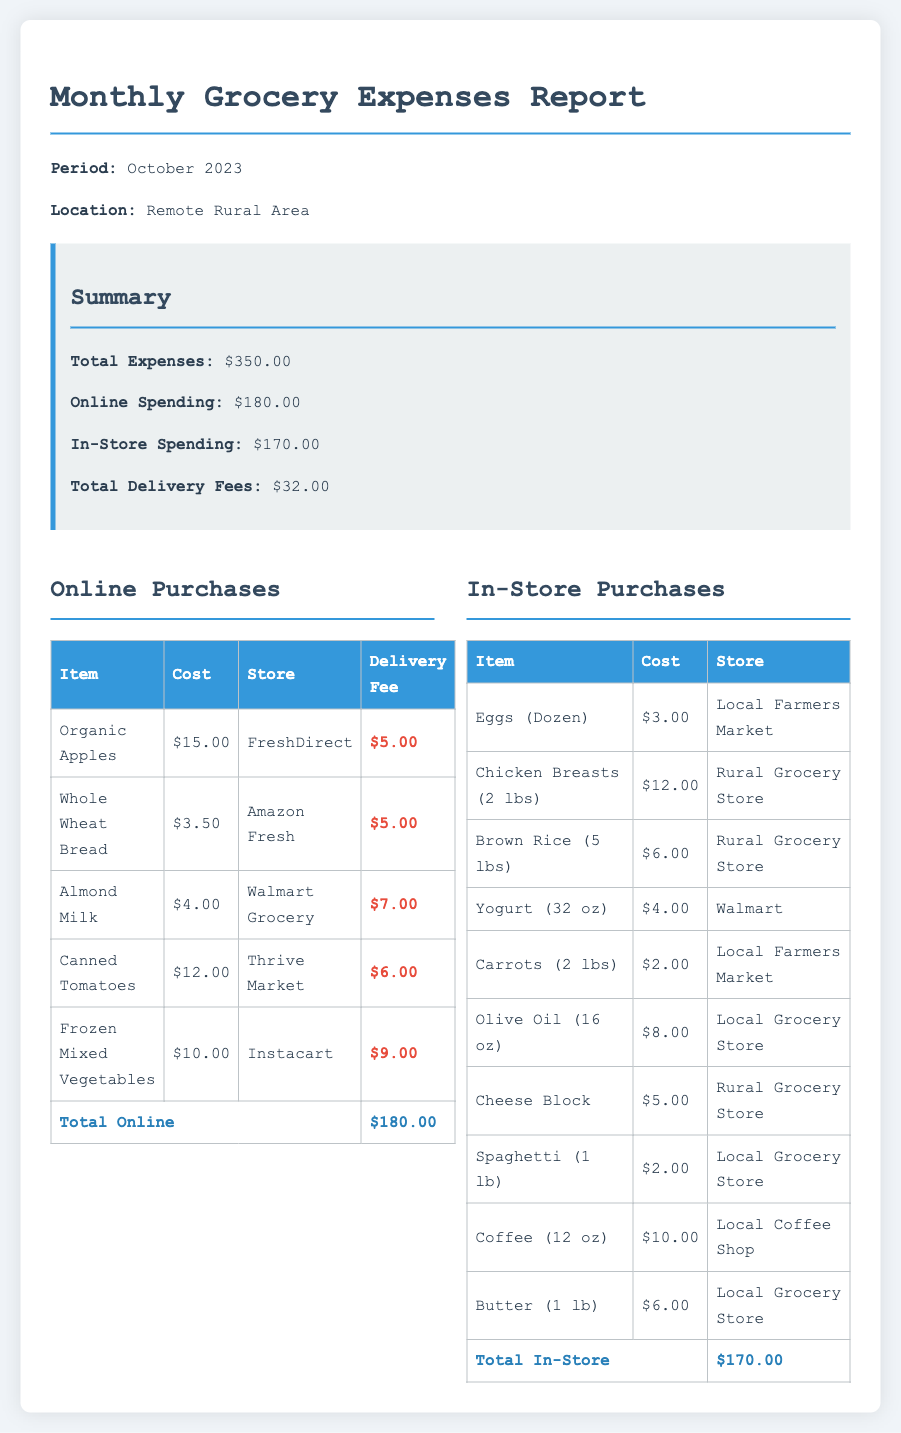What is the total grocery expense for October 2023? The total grocery expense is stated in the summary section as $350.00.
Answer: $350.00 How much was spent on online grocery purchases? The summary part of the report indicates that online spending amounts to $180.00.
Answer: $180.00 What is the total amount of delivery fees? The report specifies the total delivery fees in the summary, which are $32.00.
Answer: $32.00 What item had the highest delivery fee associated with it? The online purchases table shows that Frozen Mixed Vegetables had the highest delivery fee of $9.00.
Answer: Frozen Mixed Vegetables Which store provided the Organic Apples? The online purchases table lists FreshDirect as the store for Organic Apples.
Answer: FreshDirect What was the cost of Chicken Breasts in-store? The in-store purchases table indicates that Chicken Breasts (2 lbs) cost $12.00.
Answer: $12.00 How much did the Local Farmers Market contribute to in-store purchases? The in-store section mentions that three items were bought from the Local Farmers Market, which totals $5.00 (Eggs) + $2.00 (Carrots) = $7.00.
Answer: $7.00 What is the total for in-store purchases? According to the in-store purchases section, the total for in-store spending is $170.00.
Answer: $170.00 What item has the lowest cost in online purchases? The online purchases table shows Whole Wheat Bread at $3.50 as the lowest cost item.
Answer: Whole Wheat Bread 